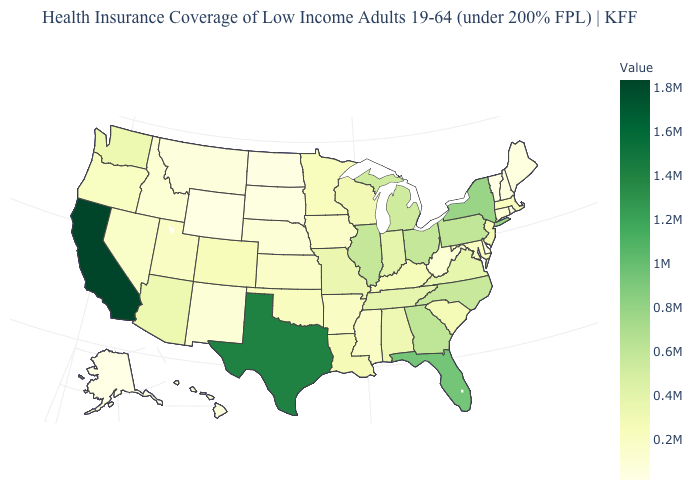Does North Dakota have a lower value than Tennessee?
Quick response, please. Yes. Which states have the highest value in the USA?
Give a very brief answer. California. Which states have the lowest value in the USA?
Be succinct. Vermont. Is the legend a continuous bar?
Answer briefly. Yes. Does California have the highest value in the USA?
Concise answer only. Yes. Which states have the lowest value in the USA?
Write a very short answer. Vermont. 